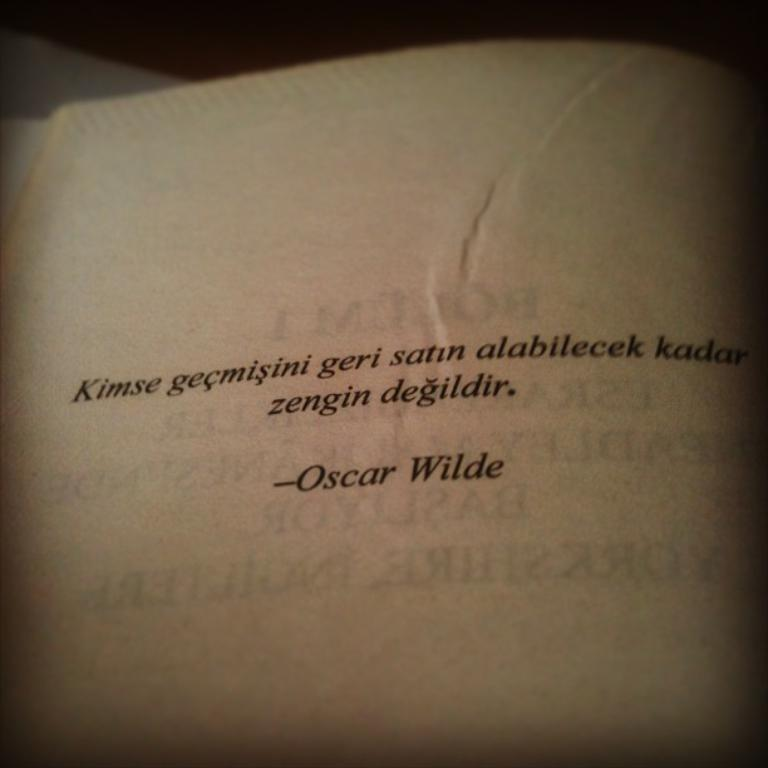Provide a one-sentence caption for the provided image. A quote on the page of a book in German from Oscar WIlde. 